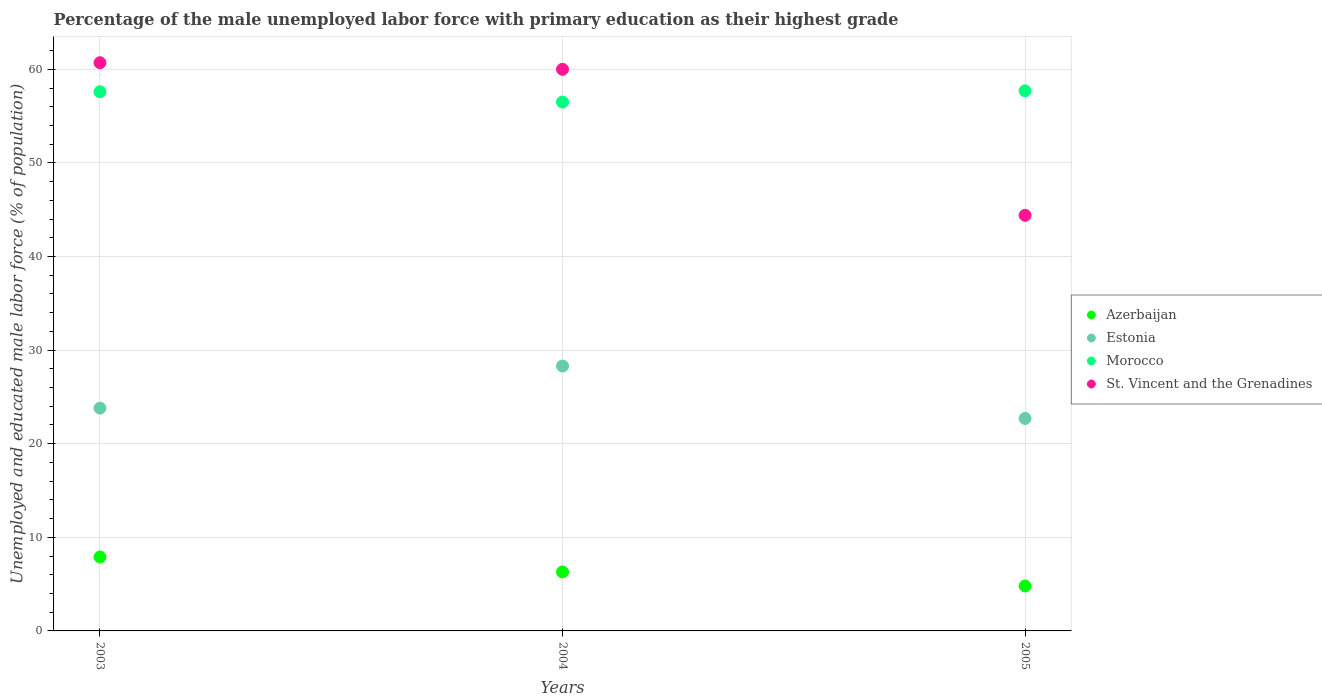What is the percentage of the unemployed male labor force with primary education in Estonia in 2003?
Offer a very short reply. 23.8. Across all years, what is the maximum percentage of the unemployed male labor force with primary education in Morocco?
Ensure brevity in your answer.  57.7. Across all years, what is the minimum percentage of the unemployed male labor force with primary education in Estonia?
Give a very brief answer. 22.7. In which year was the percentage of the unemployed male labor force with primary education in Morocco maximum?
Offer a very short reply. 2005. In which year was the percentage of the unemployed male labor force with primary education in Azerbaijan minimum?
Give a very brief answer. 2005. What is the total percentage of the unemployed male labor force with primary education in St. Vincent and the Grenadines in the graph?
Offer a very short reply. 165.1. What is the difference between the percentage of the unemployed male labor force with primary education in St. Vincent and the Grenadines in 2003 and that in 2005?
Keep it short and to the point. 16.3. What is the average percentage of the unemployed male labor force with primary education in St. Vincent and the Grenadines per year?
Offer a terse response. 55.03. In the year 2005, what is the difference between the percentage of the unemployed male labor force with primary education in Morocco and percentage of the unemployed male labor force with primary education in Estonia?
Make the answer very short. 35. In how many years, is the percentage of the unemployed male labor force with primary education in Estonia greater than 12 %?
Provide a succinct answer. 3. What is the ratio of the percentage of the unemployed male labor force with primary education in Azerbaijan in 2003 to that in 2005?
Offer a terse response. 1.65. Is the percentage of the unemployed male labor force with primary education in Azerbaijan in 2003 less than that in 2005?
Offer a terse response. No. Is the difference between the percentage of the unemployed male labor force with primary education in Morocco in 2003 and 2004 greater than the difference between the percentage of the unemployed male labor force with primary education in Estonia in 2003 and 2004?
Keep it short and to the point. Yes. What is the difference between the highest and the second highest percentage of the unemployed male labor force with primary education in Azerbaijan?
Your answer should be compact. 1.6. What is the difference between the highest and the lowest percentage of the unemployed male labor force with primary education in St. Vincent and the Grenadines?
Offer a very short reply. 16.3. Is it the case that in every year, the sum of the percentage of the unemployed male labor force with primary education in Azerbaijan and percentage of the unemployed male labor force with primary education in Morocco  is greater than the percentage of the unemployed male labor force with primary education in Estonia?
Provide a short and direct response. Yes. Is the percentage of the unemployed male labor force with primary education in St. Vincent and the Grenadines strictly greater than the percentage of the unemployed male labor force with primary education in Azerbaijan over the years?
Ensure brevity in your answer.  Yes. How many dotlines are there?
Keep it short and to the point. 4. How many years are there in the graph?
Provide a succinct answer. 3. Are the values on the major ticks of Y-axis written in scientific E-notation?
Offer a terse response. No. Does the graph contain grids?
Give a very brief answer. Yes. How are the legend labels stacked?
Ensure brevity in your answer.  Vertical. What is the title of the graph?
Ensure brevity in your answer.  Percentage of the male unemployed labor force with primary education as their highest grade. Does "Guatemala" appear as one of the legend labels in the graph?
Your answer should be very brief. No. What is the label or title of the Y-axis?
Your answer should be very brief. Unemployed and educated male labor force (% of population). What is the Unemployed and educated male labor force (% of population) in Azerbaijan in 2003?
Offer a very short reply. 7.9. What is the Unemployed and educated male labor force (% of population) of Estonia in 2003?
Provide a succinct answer. 23.8. What is the Unemployed and educated male labor force (% of population) of Morocco in 2003?
Keep it short and to the point. 57.6. What is the Unemployed and educated male labor force (% of population) of St. Vincent and the Grenadines in 2003?
Offer a terse response. 60.7. What is the Unemployed and educated male labor force (% of population) in Azerbaijan in 2004?
Ensure brevity in your answer.  6.3. What is the Unemployed and educated male labor force (% of population) of Estonia in 2004?
Make the answer very short. 28.3. What is the Unemployed and educated male labor force (% of population) of Morocco in 2004?
Your response must be concise. 56.5. What is the Unemployed and educated male labor force (% of population) in Azerbaijan in 2005?
Your answer should be very brief. 4.8. What is the Unemployed and educated male labor force (% of population) in Estonia in 2005?
Your answer should be compact. 22.7. What is the Unemployed and educated male labor force (% of population) in Morocco in 2005?
Ensure brevity in your answer.  57.7. What is the Unemployed and educated male labor force (% of population) in St. Vincent and the Grenadines in 2005?
Offer a very short reply. 44.4. Across all years, what is the maximum Unemployed and educated male labor force (% of population) of Azerbaijan?
Your response must be concise. 7.9. Across all years, what is the maximum Unemployed and educated male labor force (% of population) of Estonia?
Keep it short and to the point. 28.3. Across all years, what is the maximum Unemployed and educated male labor force (% of population) of Morocco?
Provide a short and direct response. 57.7. Across all years, what is the maximum Unemployed and educated male labor force (% of population) of St. Vincent and the Grenadines?
Keep it short and to the point. 60.7. Across all years, what is the minimum Unemployed and educated male labor force (% of population) of Azerbaijan?
Ensure brevity in your answer.  4.8. Across all years, what is the minimum Unemployed and educated male labor force (% of population) of Estonia?
Offer a terse response. 22.7. Across all years, what is the minimum Unemployed and educated male labor force (% of population) of Morocco?
Give a very brief answer. 56.5. Across all years, what is the minimum Unemployed and educated male labor force (% of population) of St. Vincent and the Grenadines?
Make the answer very short. 44.4. What is the total Unemployed and educated male labor force (% of population) in Estonia in the graph?
Your answer should be compact. 74.8. What is the total Unemployed and educated male labor force (% of population) of Morocco in the graph?
Ensure brevity in your answer.  171.8. What is the total Unemployed and educated male labor force (% of population) of St. Vincent and the Grenadines in the graph?
Keep it short and to the point. 165.1. What is the difference between the Unemployed and educated male labor force (% of population) in Morocco in 2003 and that in 2004?
Make the answer very short. 1.1. What is the difference between the Unemployed and educated male labor force (% of population) in St. Vincent and the Grenadines in 2003 and that in 2004?
Keep it short and to the point. 0.7. What is the difference between the Unemployed and educated male labor force (% of population) of Azerbaijan in 2003 and that in 2005?
Provide a succinct answer. 3.1. What is the difference between the Unemployed and educated male labor force (% of population) in Morocco in 2003 and that in 2005?
Your answer should be compact. -0.1. What is the difference between the Unemployed and educated male labor force (% of population) of Estonia in 2004 and that in 2005?
Provide a succinct answer. 5.6. What is the difference between the Unemployed and educated male labor force (% of population) in Morocco in 2004 and that in 2005?
Keep it short and to the point. -1.2. What is the difference between the Unemployed and educated male labor force (% of population) of Azerbaijan in 2003 and the Unemployed and educated male labor force (% of population) of Estonia in 2004?
Keep it short and to the point. -20.4. What is the difference between the Unemployed and educated male labor force (% of population) of Azerbaijan in 2003 and the Unemployed and educated male labor force (% of population) of Morocco in 2004?
Offer a terse response. -48.6. What is the difference between the Unemployed and educated male labor force (% of population) of Azerbaijan in 2003 and the Unemployed and educated male labor force (% of population) of St. Vincent and the Grenadines in 2004?
Your response must be concise. -52.1. What is the difference between the Unemployed and educated male labor force (% of population) in Estonia in 2003 and the Unemployed and educated male labor force (% of population) in Morocco in 2004?
Your answer should be very brief. -32.7. What is the difference between the Unemployed and educated male labor force (% of population) of Estonia in 2003 and the Unemployed and educated male labor force (% of population) of St. Vincent and the Grenadines in 2004?
Give a very brief answer. -36.2. What is the difference between the Unemployed and educated male labor force (% of population) of Morocco in 2003 and the Unemployed and educated male labor force (% of population) of St. Vincent and the Grenadines in 2004?
Provide a short and direct response. -2.4. What is the difference between the Unemployed and educated male labor force (% of population) in Azerbaijan in 2003 and the Unemployed and educated male labor force (% of population) in Estonia in 2005?
Keep it short and to the point. -14.8. What is the difference between the Unemployed and educated male labor force (% of population) in Azerbaijan in 2003 and the Unemployed and educated male labor force (% of population) in Morocco in 2005?
Give a very brief answer. -49.8. What is the difference between the Unemployed and educated male labor force (% of population) of Azerbaijan in 2003 and the Unemployed and educated male labor force (% of population) of St. Vincent and the Grenadines in 2005?
Your answer should be compact. -36.5. What is the difference between the Unemployed and educated male labor force (% of population) in Estonia in 2003 and the Unemployed and educated male labor force (% of population) in Morocco in 2005?
Your response must be concise. -33.9. What is the difference between the Unemployed and educated male labor force (% of population) of Estonia in 2003 and the Unemployed and educated male labor force (% of population) of St. Vincent and the Grenadines in 2005?
Provide a succinct answer. -20.6. What is the difference between the Unemployed and educated male labor force (% of population) in Morocco in 2003 and the Unemployed and educated male labor force (% of population) in St. Vincent and the Grenadines in 2005?
Provide a short and direct response. 13.2. What is the difference between the Unemployed and educated male labor force (% of population) of Azerbaijan in 2004 and the Unemployed and educated male labor force (% of population) of Estonia in 2005?
Your response must be concise. -16.4. What is the difference between the Unemployed and educated male labor force (% of population) in Azerbaijan in 2004 and the Unemployed and educated male labor force (% of population) in Morocco in 2005?
Your response must be concise. -51.4. What is the difference between the Unemployed and educated male labor force (% of population) in Azerbaijan in 2004 and the Unemployed and educated male labor force (% of population) in St. Vincent and the Grenadines in 2005?
Provide a succinct answer. -38.1. What is the difference between the Unemployed and educated male labor force (% of population) of Estonia in 2004 and the Unemployed and educated male labor force (% of population) of Morocco in 2005?
Ensure brevity in your answer.  -29.4. What is the difference between the Unemployed and educated male labor force (% of population) of Estonia in 2004 and the Unemployed and educated male labor force (% of population) of St. Vincent and the Grenadines in 2005?
Offer a terse response. -16.1. What is the difference between the Unemployed and educated male labor force (% of population) of Morocco in 2004 and the Unemployed and educated male labor force (% of population) of St. Vincent and the Grenadines in 2005?
Make the answer very short. 12.1. What is the average Unemployed and educated male labor force (% of population) of Azerbaijan per year?
Offer a terse response. 6.33. What is the average Unemployed and educated male labor force (% of population) in Estonia per year?
Provide a short and direct response. 24.93. What is the average Unemployed and educated male labor force (% of population) of Morocco per year?
Provide a succinct answer. 57.27. What is the average Unemployed and educated male labor force (% of population) of St. Vincent and the Grenadines per year?
Make the answer very short. 55.03. In the year 2003, what is the difference between the Unemployed and educated male labor force (% of population) of Azerbaijan and Unemployed and educated male labor force (% of population) of Estonia?
Make the answer very short. -15.9. In the year 2003, what is the difference between the Unemployed and educated male labor force (% of population) in Azerbaijan and Unemployed and educated male labor force (% of population) in Morocco?
Your response must be concise. -49.7. In the year 2003, what is the difference between the Unemployed and educated male labor force (% of population) of Azerbaijan and Unemployed and educated male labor force (% of population) of St. Vincent and the Grenadines?
Ensure brevity in your answer.  -52.8. In the year 2003, what is the difference between the Unemployed and educated male labor force (% of population) in Estonia and Unemployed and educated male labor force (% of population) in Morocco?
Provide a short and direct response. -33.8. In the year 2003, what is the difference between the Unemployed and educated male labor force (% of population) of Estonia and Unemployed and educated male labor force (% of population) of St. Vincent and the Grenadines?
Keep it short and to the point. -36.9. In the year 2004, what is the difference between the Unemployed and educated male labor force (% of population) of Azerbaijan and Unemployed and educated male labor force (% of population) of Morocco?
Give a very brief answer. -50.2. In the year 2004, what is the difference between the Unemployed and educated male labor force (% of population) in Azerbaijan and Unemployed and educated male labor force (% of population) in St. Vincent and the Grenadines?
Provide a short and direct response. -53.7. In the year 2004, what is the difference between the Unemployed and educated male labor force (% of population) of Estonia and Unemployed and educated male labor force (% of population) of Morocco?
Your answer should be compact. -28.2. In the year 2004, what is the difference between the Unemployed and educated male labor force (% of population) in Estonia and Unemployed and educated male labor force (% of population) in St. Vincent and the Grenadines?
Give a very brief answer. -31.7. In the year 2004, what is the difference between the Unemployed and educated male labor force (% of population) of Morocco and Unemployed and educated male labor force (% of population) of St. Vincent and the Grenadines?
Ensure brevity in your answer.  -3.5. In the year 2005, what is the difference between the Unemployed and educated male labor force (% of population) of Azerbaijan and Unemployed and educated male labor force (% of population) of Estonia?
Make the answer very short. -17.9. In the year 2005, what is the difference between the Unemployed and educated male labor force (% of population) in Azerbaijan and Unemployed and educated male labor force (% of population) in Morocco?
Provide a short and direct response. -52.9. In the year 2005, what is the difference between the Unemployed and educated male labor force (% of population) of Azerbaijan and Unemployed and educated male labor force (% of population) of St. Vincent and the Grenadines?
Your answer should be very brief. -39.6. In the year 2005, what is the difference between the Unemployed and educated male labor force (% of population) of Estonia and Unemployed and educated male labor force (% of population) of Morocco?
Offer a very short reply. -35. In the year 2005, what is the difference between the Unemployed and educated male labor force (% of population) of Estonia and Unemployed and educated male labor force (% of population) of St. Vincent and the Grenadines?
Your answer should be compact. -21.7. What is the ratio of the Unemployed and educated male labor force (% of population) of Azerbaijan in 2003 to that in 2004?
Your answer should be very brief. 1.25. What is the ratio of the Unemployed and educated male labor force (% of population) in Estonia in 2003 to that in 2004?
Provide a short and direct response. 0.84. What is the ratio of the Unemployed and educated male labor force (% of population) in Morocco in 2003 to that in 2004?
Offer a terse response. 1.02. What is the ratio of the Unemployed and educated male labor force (% of population) in St. Vincent and the Grenadines in 2003 to that in 2004?
Ensure brevity in your answer.  1.01. What is the ratio of the Unemployed and educated male labor force (% of population) of Azerbaijan in 2003 to that in 2005?
Keep it short and to the point. 1.65. What is the ratio of the Unemployed and educated male labor force (% of population) of Estonia in 2003 to that in 2005?
Provide a short and direct response. 1.05. What is the ratio of the Unemployed and educated male labor force (% of population) of Morocco in 2003 to that in 2005?
Your answer should be compact. 1. What is the ratio of the Unemployed and educated male labor force (% of population) of St. Vincent and the Grenadines in 2003 to that in 2005?
Give a very brief answer. 1.37. What is the ratio of the Unemployed and educated male labor force (% of population) of Azerbaijan in 2004 to that in 2005?
Keep it short and to the point. 1.31. What is the ratio of the Unemployed and educated male labor force (% of population) in Estonia in 2004 to that in 2005?
Your response must be concise. 1.25. What is the ratio of the Unemployed and educated male labor force (% of population) of Morocco in 2004 to that in 2005?
Your answer should be compact. 0.98. What is the ratio of the Unemployed and educated male labor force (% of population) in St. Vincent and the Grenadines in 2004 to that in 2005?
Provide a short and direct response. 1.35. What is the difference between the highest and the second highest Unemployed and educated male labor force (% of population) in Estonia?
Give a very brief answer. 4.5. What is the difference between the highest and the lowest Unemployed and educated male labor force (% of population) in Azerbaijan?
Your answer should be very brief. 3.1. What is the difference between the highest and the lowest Unemployed and educated male labor force (% of population) of Estonia?
Your answer should be compact. 5.6. What is the difference between the highest and the lowest Unemployed and educated male labor force (% of population) of Morocco?
Keep it short and to the point. 1.2. What is the difference between the highest and the lowest Unemployed and educated male labor force (% of population) in St. Vincent and the Grenadines?
Ensure brevity in your answer.  16.3. 